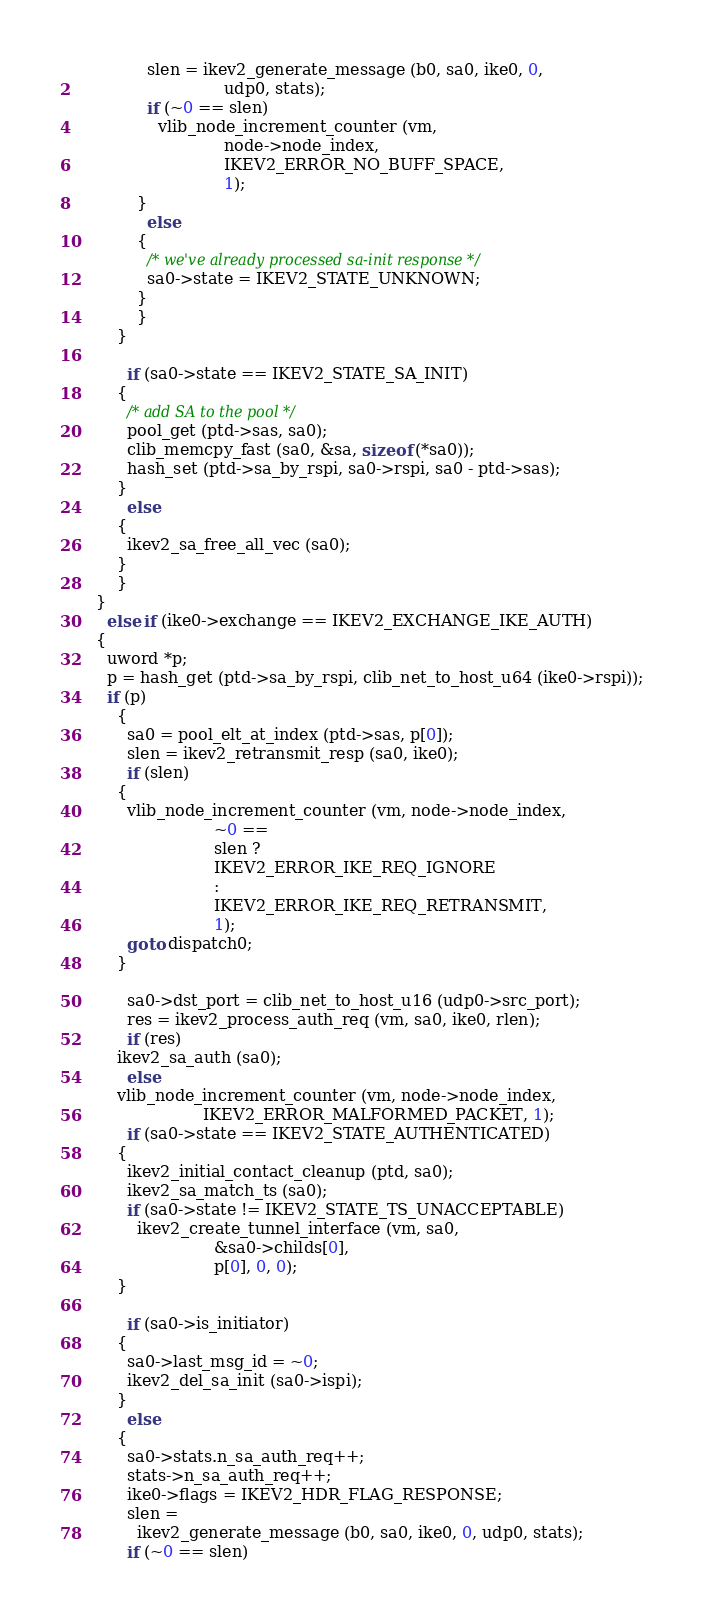Convert code to text. <code><loc_0><loc_0><loc_500><loc_500><_C_>			  slen = ikev2_generate_message (b0, sa0, ike0, 0,
							 udp0, stats);
			  if (~0 == slen)
			    vlib_node_increment_counter (vm,
							 node->node_index,
							 IKEV2_ERROR_NO_BUFF_SPACE,
							 1);
			}
		      else
			{
			  /* we've already processed sa-init response */
			  sa0->state = IKEV2_STATE_UNKNOWN;
			}
		    }
		}

	      if (sa0->state == IKEV2_STATE_SA_INIT)
		{
		  /* add SA to the pool */
		  pool_get (ptd->sas, sa0);
		  clib_memcpy_fast (sa0, &sa, sizeof (*sa0));
		  hash_set (ptd->sa_by_rspi, sa0->rspi, sa0 - ptd->sas);
		}
	      else
		{
		  ikev2_sa_free_all_vec (sa0);
		}
	    }
	}
      else if (ike0->exchange == IKEV2_EXCHANGE_IKE_AUTH)
	{
	  uword *p;
	  p = hash_get (ptd->sa_by_rspi, clib_net_to_host_u64 (ike0->rspi));
	  if (p)
	    {
	      sa0 = pool_elt_at_index (ptd->sas, p[0]);
	      slen = ikev2_retransmit_resp (sa0, ike0);
	      if (slen)
		{
		  vlib_node_increment_counter (vm, node->node_index,
					       ~0 ==
					       slen ?
					       IKEV2_ERROR_IKE_REQ_IGNORE
					       :
					       IKEV2_ERROR_IKE_REQ_RETRANSMIT,
					       1);
		  goto dispatch0;
		}

	      sa0->dst_port = clib_net_to_host_u16 (udp0->src_port);
	      res = ikev2_process_auth_req (vm, sa0, ike0, rlen);
	      if (res)
		ikev2_sa_auth (sa0);
	      else
		vlib_node_increment_counter (vm, node->node_index,
					     IKEV2_ERROR_MALFORMED_PACKET, 1);
	      if (sa0->state == IKEV2_STATE_AUTHENTICATED)
		{
		  ikev2_initial_contact_cleanup (ptd, sa0);
		  ikev2_sa_match_ts (sa0);
		  if (sa0->state != IKEV2_STATE_TS_UNACCEPTABLE)
		    ikev2_create_tunnel_interface (vm, sa0,
						   &sa0->childs[0],
						   p[0], 0, 0);
		}

	      if (sa0->is_initiator)
		{
		  sa0->last_msg_id = ~0;
		  ikev2_del_sa_init (sa0->ispi);
		}
	      else
		{
		  sa0->stats.n_sa_auth_req++;
		  stats->n_sa_auth_req++;
		  ike0->flags = IKEV2_HDR_FLAG_RESPONSE;
		  slen =
		    ikev2_generate_message (b0, sa0, ike0, 0, udp0, stats);
		  if (~0 == slen)</code> 